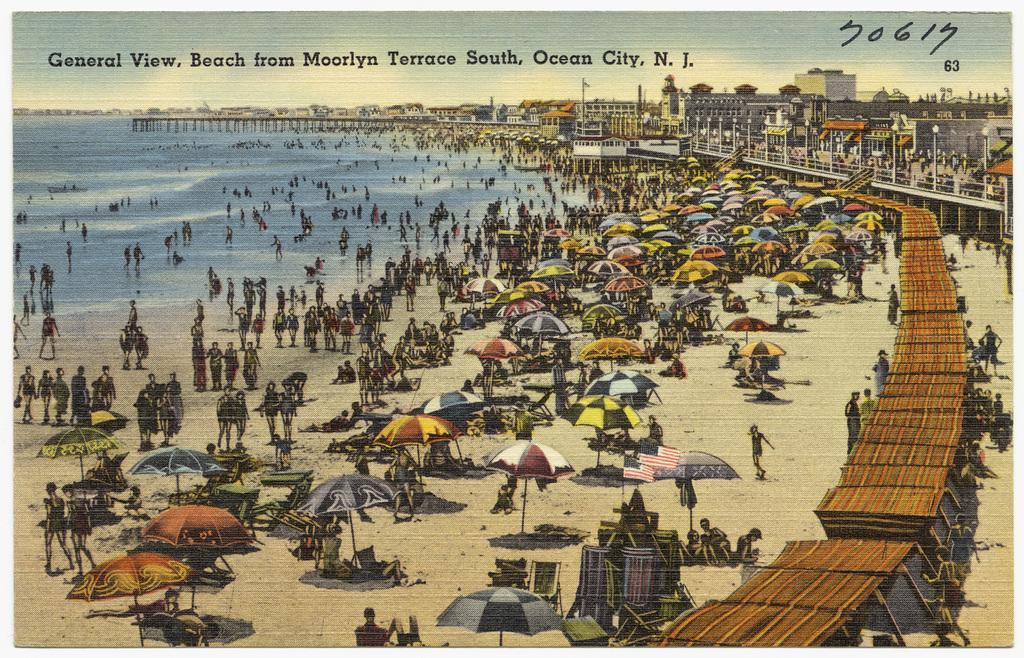What city is this beach located?
Your answer should be compact. Ocean city. 